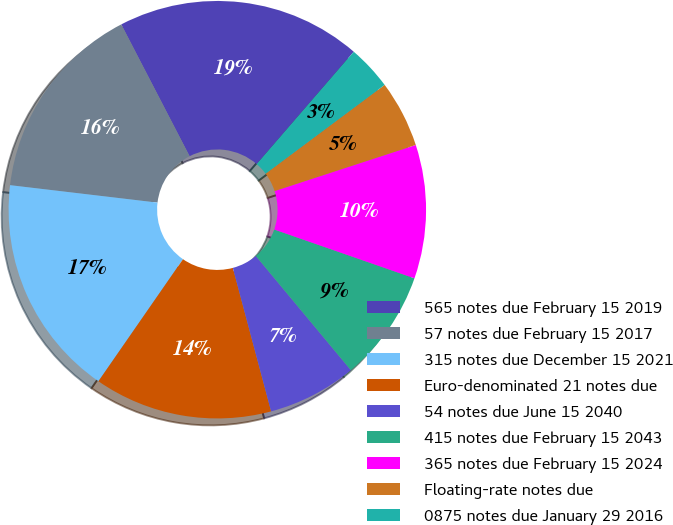Convert chart. <chart><loc_0><loc_0><loc_500><loc_500><pie_chart><fcel>565 notes due February 15 2019<fcel>57 notes due February 15 2017<fcel>315 notes due December 15 2021<fcel>Euro-denominated 21 notes due<fcel>54 notes due June 15 2040<fcel>415 notes due February 15 2043<fcel>365 notes due February 15 2024<fcel>Floating-rate notes due<fcel>0875 notes due January 29 2016<nl><fcel>18.95%<fcel>15.51%<fcel>17.23%<fcel>13.79%<fcel>6.9%<fcel>8.62%<fcel>10.35%<fcel>5.18%<fcel>3.46%<nl></chart> 